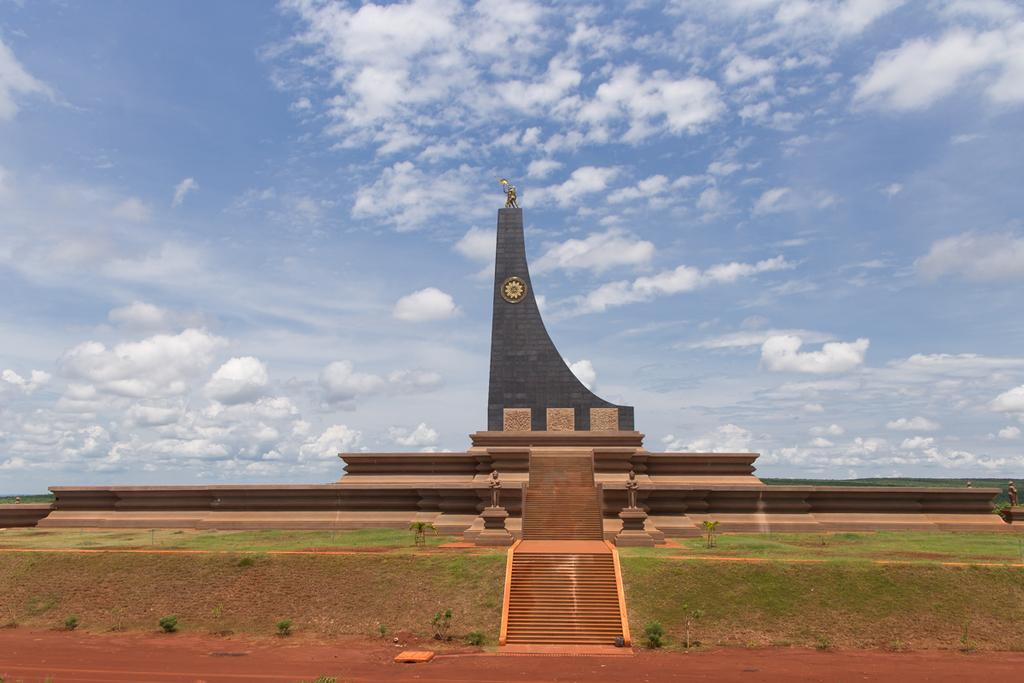What type of structure is present in the image? There is a building in the image. What architectural feature can be seen in the image? There are stairs in the image. What type of ground surface is visible at the bottom of the image? There is sand and grass at the bottom of the image. What type of vegetation is present at the bottom of the image? There are plants at the bottom of the image. What is visible in the sky in the image? The sky is visible at the top of the image. What does the image smell like? The image does not have a smell, as it is a visual representation and not a physical object. 